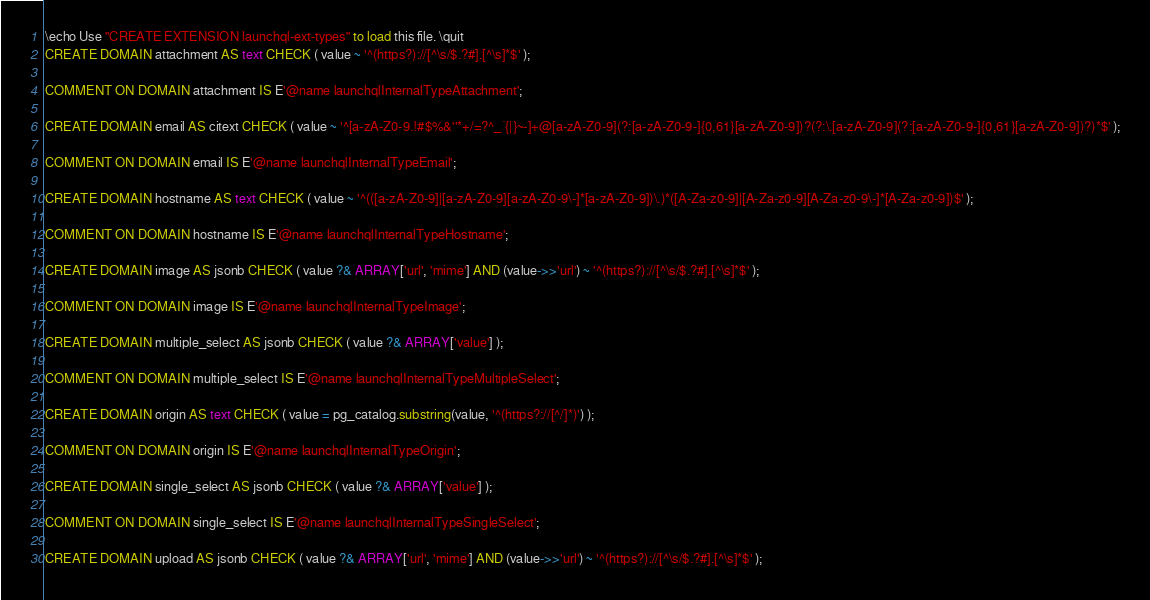<code> <loc_0><loc_0><loc_500><loc_500><_SQL_>\echo Use "CREATE EXTENSION launchql-ext-types" to load this file. \quit
CREATE DOMAIN attachment AS text CHECK ( value ~ '^(https?)://[^\s/$.?#].[^\s]*$' );

COMMENT ON DOMAIN attachment IS E'@name launchqlInternalTypeAttachment';

CREATE DOMAIN email AS citext CHECK ( value ~ '^[a-zA-Z0-9.!#$%&''*+/=?^_`{|}~-]+@[a-zA-Z0-9](?:[a-zA-Z0-9-]{0,61}[a-zA-Z0-9])?(?:\.[a-zA-Z0-9](?:[a-zA-Z0-9-]{0,61}[a-zA-Z0-9])?)*$' );

COMMENT ON DOMAIN email IS E'@name launchqlInternalTypeEmail';

CREATE DOMAIN hostname AS text CHECK ( value ~ '^(([a-zA-Z0-9]|[a-zA-Z0-9][a-zA-Z0-9\-]*[a-zA-Z0-9])\.)*([A-Za-z0-9]|[A-Za-z0-9][A-Za-z0-9\-]*[A-Za-z0-9])$' );

COMMENT ON DOMAIN hostname IS E'@name launchqlInternalTypeHostname';

CREATE DOMAIN image AS jsonb CHECK ( value ?& ARRAY['url', 'mime'] AND (value->>'url') ~ '^(https?)://[^\s/$.?#].[^\s]*$' );

COMMENT ON DOMAIN image IS E'@name launchqlInternalTypeImage';

CREATE DOMAIN multiple_select AS jsonb CHECK ( value ?& ARRAY['value'] );

COMMENT ON DOMAIN multiple_select IS E'@name launchqlInternalTypeMultipleSelect';

CREATE DOMAIN origin AS text CHECK ( value = pg_catalog.substring(value, '^(https?://[^/]*)') );

COMMENT ON DOMAIN origin IS E'@name launchqlInternalTypeOrigin';

CREATE DOMAIN single_select AS jsonb CHECK ( value ?& ARRAY['value'] );

COMMENT ON DOMAIN single_select IS E'@name launchqlInternalTypeSingleSelect';

CREATE DOMAIN upload AS jsonb CHECK ( value ?& ARRAY['url', 'mime'] AND (value->>'url') ~ '^(https?)://[^\s/$.?#].[^\s]*$' );
</code> 